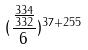<formula> <loc_0><loc_0><loc_500><loc_500>( \frac { \frac { 3 3 4 } { 3 3 2 } } { 6 } ) ^ { 3 7 + 2 5 5 }</formula> 